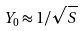Convert formula to latex. <formula><loc_0><loc_0><loc_500><loc_500>Y _ { 0 } \approx 1 / \sqrt { S }</formula> 